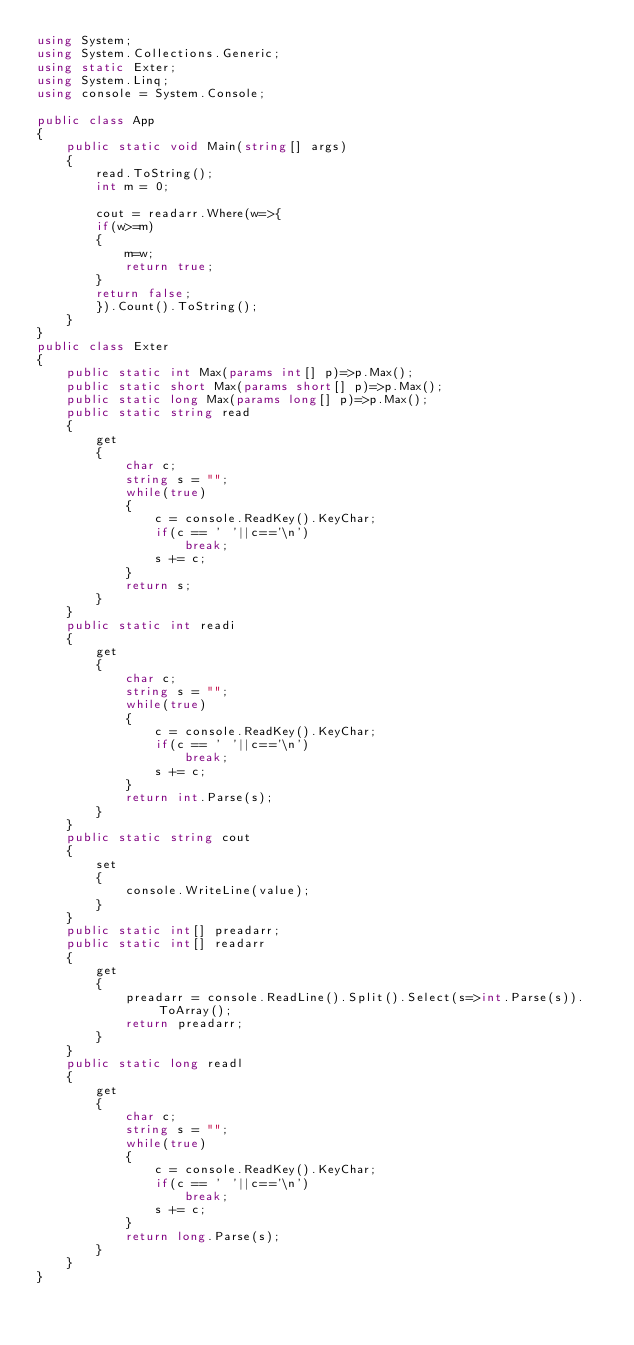Convert code to text. <code><loc_0><loc_0><loc_500><loc_500><_C#_>using System;
using System.Collections.Generic;
using static Exter;
using System.Linq;
using console = System.Console;

public class App
{
    public static void Main(string[] args)
    {
        read.ToString();
        int m = 0;
        
        cout = readarr.Where(w=>{
        if(w>=m)
        {
            m=w;
            return true;
        }
        return false;
        }).Count().ToString();
    }
}
public class Exter
{
    public static int Max(params int[] p)=>p.Max();
    public static short Max(params short[] p)=>p.Max();
    public static long Max(params long[] p)=>p.Max();
    public static string read
    {
        get
        {
            char c;
            string s = "";
            while(true)
            {
                c = console.ReadKey().KeyChar;
                if(c == ' '||c=='\n')
                    break;
                s += c;
            }
            return s;
        }
    }
    public static int readi
    {
        get
        {
            char c;
            string s = "";
            while(true)
            {
                c = console.ReadKey().KeyChar;
                if(c == ' '||c=='\n')
                    break;
                s += c;
            }
            return int.Parse(s);
        }
    }
    public static string cout
    {
        set
        {
            console.WriteLine(value);
        }
    }
    public static int[] preadarr;
    public static int[] readarr
    {
        get
        {
            preadarr = console.ReadLine().Split().Select(s=>int.Parse(s)).ToArray();
            return preadarr;
        }
    }
    public static long readl
    {
        get
        {
            char c;
            string s = "";
            while(true)
            {
                c = console.ReadKey().KeyChar;
                if(c == ' '||c=='\n')
                    break;
                s += c;
            }
            return long.Parse(s);
        }
    }
}</code> 